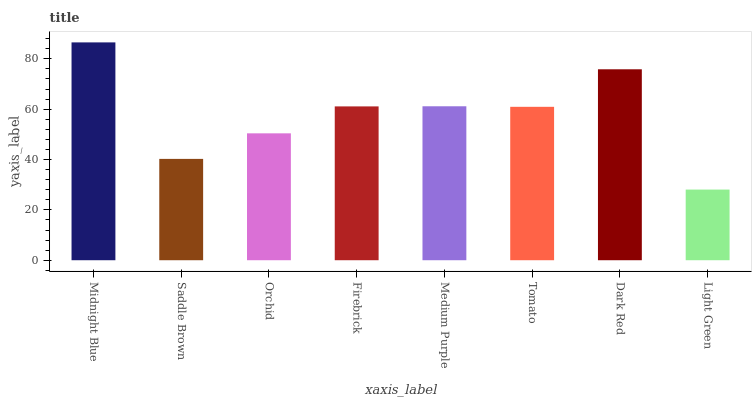Is Saddle Brown the minimum?
Answer yes or no. No. Is Saddle Brown the maximum?
Answer yes or no. No. Is Midnight Blue greater than Saddle Brown?
Answer yes or no. Yes. Is Saddle Brown less than Midnight Blue?
Answer yes or no. Yes. Is Saddle Brown greater than Midnight Blue?
Answer yes or no. No. Is Midnight Blue less than Saddle Brown?
Answer yes or no. No. Is Firebrick the high median?
Answer yes or no. Yes. Is Tomato the low median?
Answer yes or no. Yes. Is Orchid the high median?
Answer yes or no. No. Is Midnight Blue the low median?
Answer yes or no. No. 